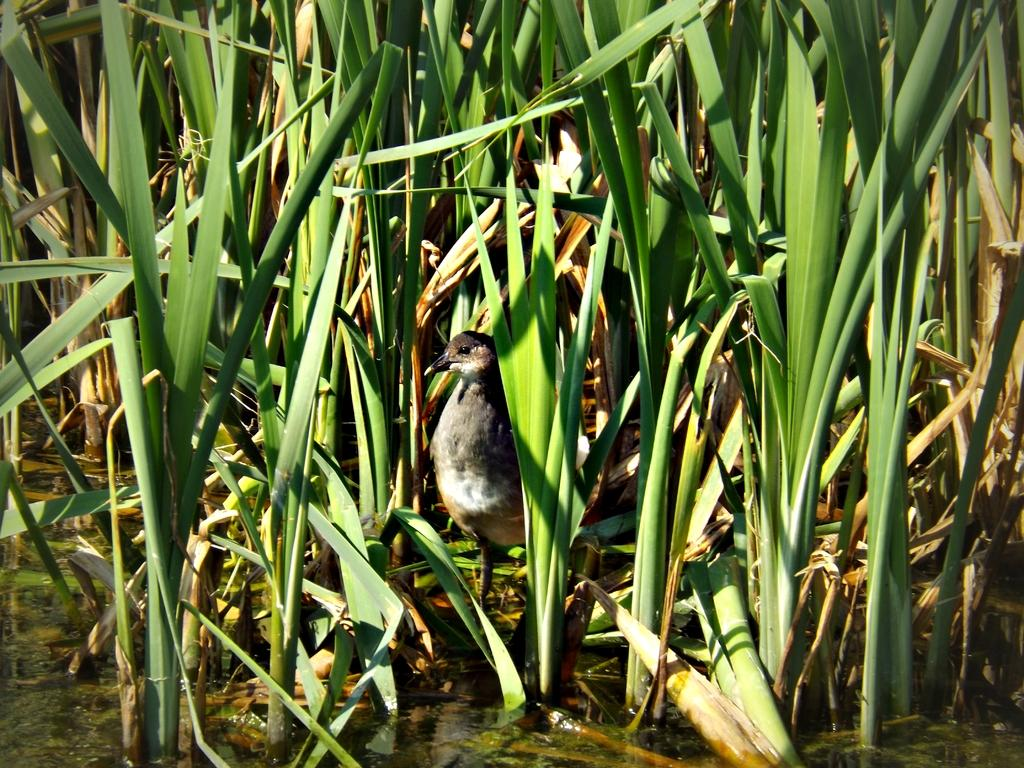What type of animal is in the picture? There is a bird in the picture. Where is the bird located in relation to other elements in the image? The bird is standing near water. What can be seen at the top of the image? There are plants visible at the top of the image. What is present on the left side of the image? There are leaves on the left side of the image. What type of faucet can be seen in the image? There is no faucet present in the image. What is the bird's reaction to the surprise in the image? There is no surprise depicted in the image, so the bird's reaction cannot be determined. 